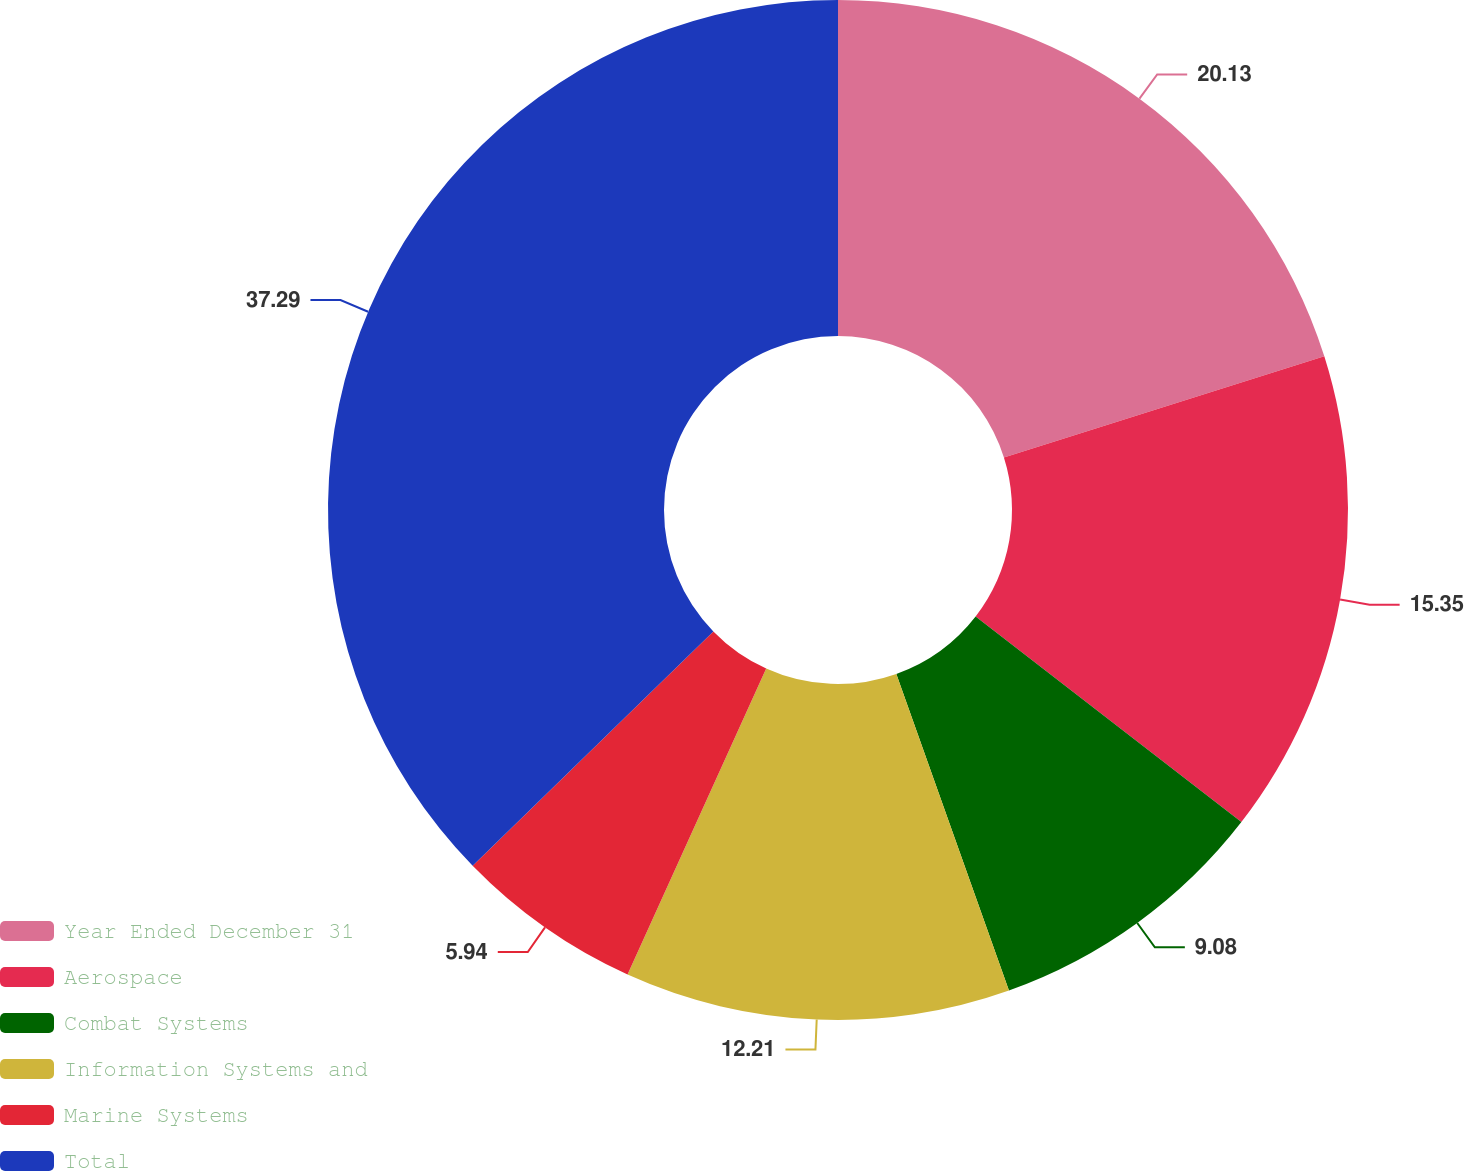Convert chart. <chart><loc_0><loc_0><loc_500><loc_500><pie_chart><fcel>Year Ended December 31<fcel>Aerospace<fcel>Combat Systems<fcel>Information Systems and<fcel>Marine Systems<fcel>Total<nl><fcel>20.13%<fcel>15.35%<fcel>9.08%<fcel>12.21%<fcel>5.94%<fcel>37.29%<nl></chart> 